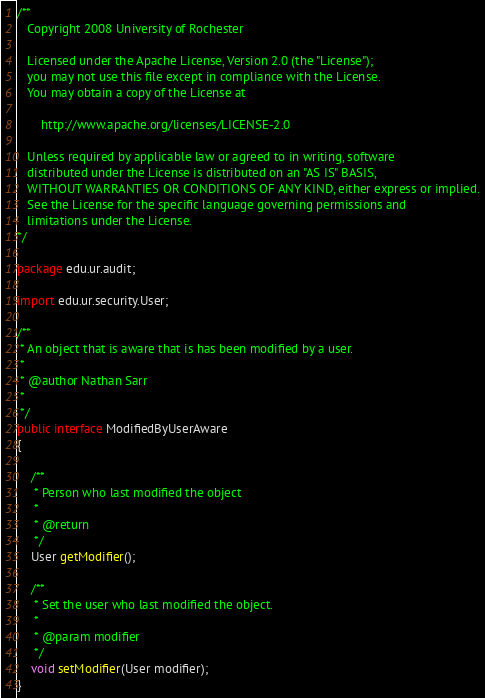<code> <loc_0><loc_0><loc_500><loc_500><_Java_>/**  
   Copyright 2008 University of Rochester

   Licensed under the Apache License, Version 2.0 (the "License");
   you may not use this file except in compliance with the License.
   You may obtain a copy of the License at

       http://www.apache.org/licenses/LICENSE-2.0

   Unless required by applicable law or agreed to in writing, software
   distributed under the License is distributed on an "AS IS" BASIS,
   WITHOUT WARRANTIES OR CONDITIONS OF ANY KIND, either express or implied.
   See the License for the specific language governing permissions and
   limitations under the License.
*/  

package edu.ur.audit;

import edu.ur.security.User;

/**
 * An object that is aware that is has been modified by a user.
 * 
 * @author Nathan Sarr
 *
 */
public interface ModifiedByUserAware
{

    /**
     * Person who last modified the object
     * 
     * @return
     */
    User getModifier();

    /**
     * Set the user who last modified the object.
     *
     * @param modifier
     */
    void setModifier(User modifier);
}
</code> 